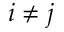<formula> <loc_0><loc_0><loc_500><loc_500>i \neq j</formula> 